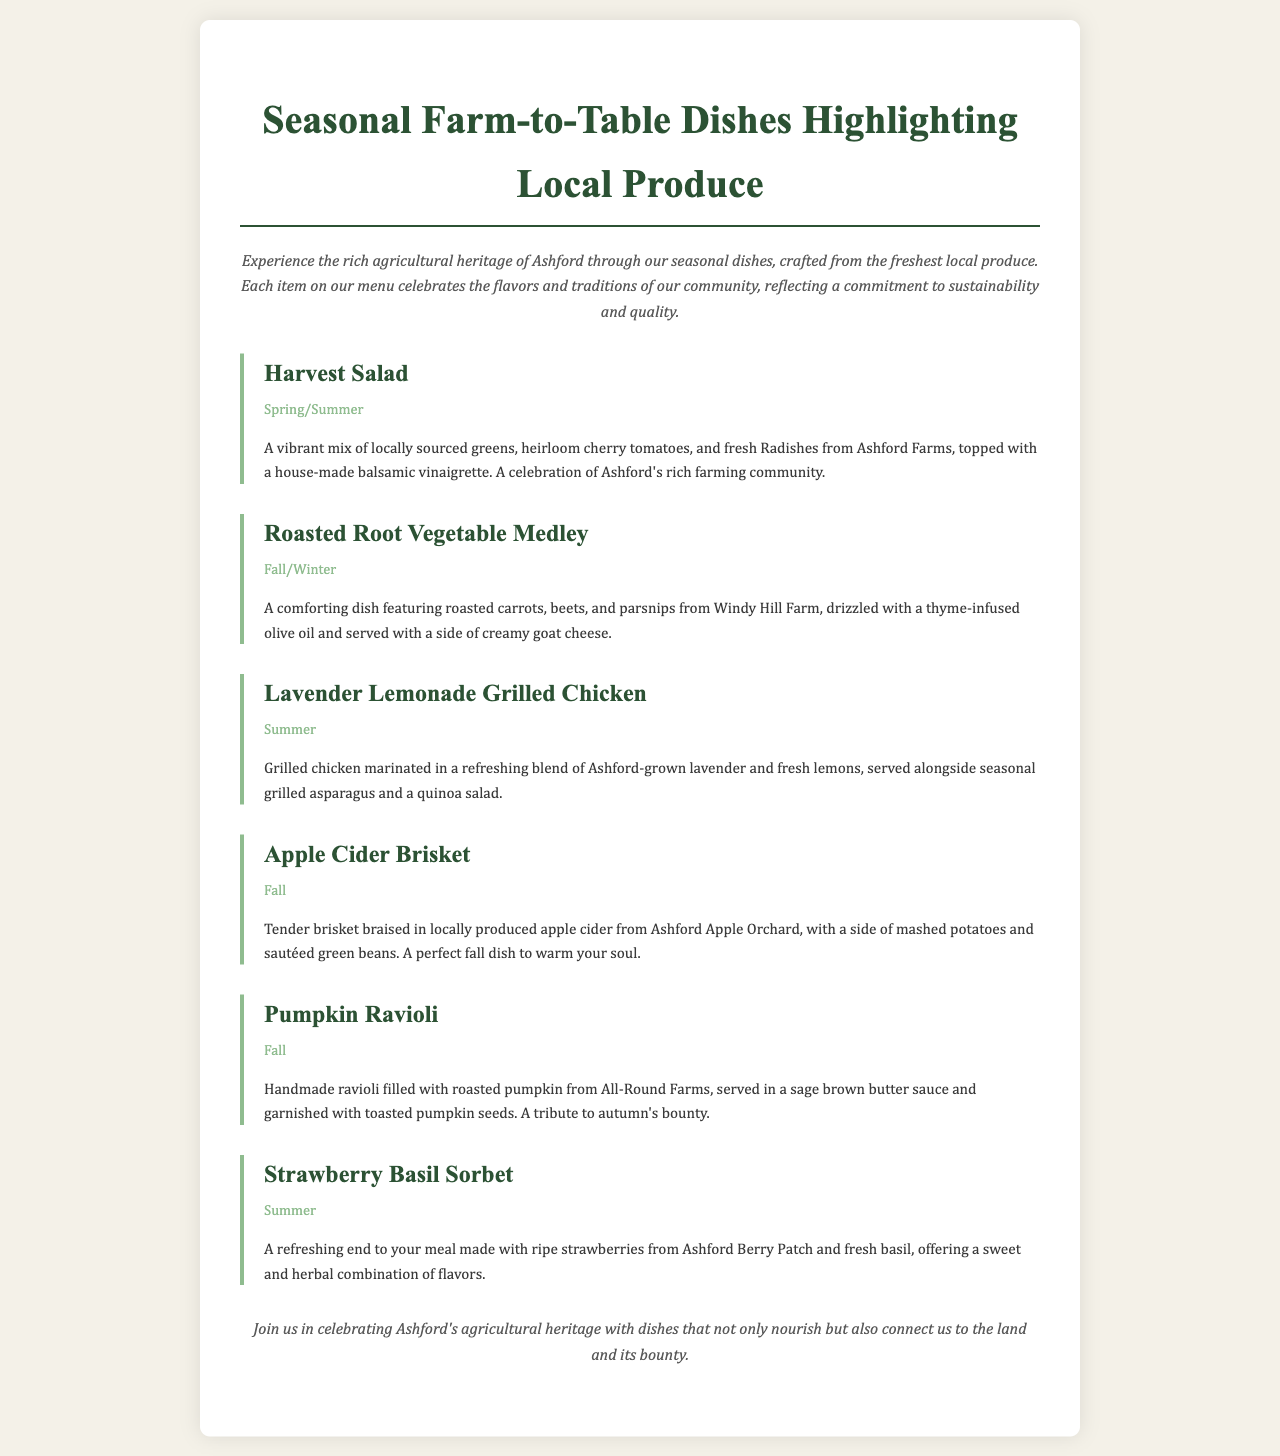What is the title of the menu? The title is prominently displayed at the top of the document, providing the theme of the food offerings.
Answer: Seasonal Farm-to-Table Dishes Highlighting Local Produce What type of dish is the Harvest Salad? The description specifies that it is a salad that incorporates local greens, tomatoes, and radishes.
Answer: Salad Which farm provides the root vegetables in the Roasted Root Vegetable Medley? The document mentions Windy Hill Farm as the source for the vegetables in this dish.
Answer: Windy Hill Farm What season is the Lavender Lemonade Grilled Chicken served in? The menu clearly indicates that this dish is available during summer.
Answer: Summer What ingredient is used in the Apple Cider Brisket? The dish description states that it is braised in locally produced apple cider.
Answer: Apple cider How many seasonal dishes are listed in the menu? By counting the entries in the menu, we can determine the total number of dishes offered.
Answer: Six Which dish serves as a refreshing dessert? The menu mentions a sorbet that fits the description of a refreshing end to the meal.
Answer: Strawberry Basil Sorbet What seasonal produce is used in the Pumpkin Ravioli? The description indicates that the ravioli is filled with roasted pumpkin.
Answer: Pumpkin 